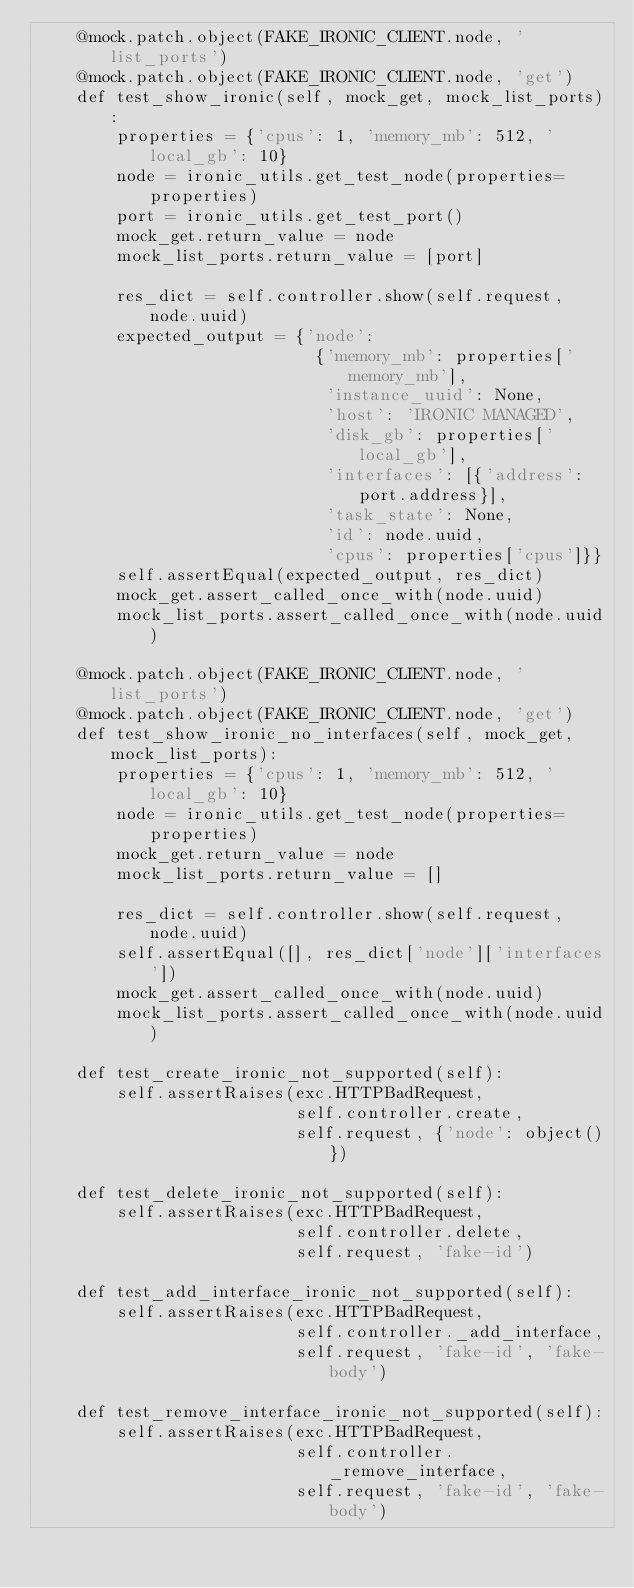<code> <loc_0><loc_0><loc_500><loc_500><_Python_>    @mock.patch.object(FAKE_IRONIC_CLIENT.node, 'list_ports')
    @mock.patch.object(FAKE_IRONIC_CLIENT.node, 'get')
    def test_show_ironic(self, mock_get, mock_list_ports):
        properties = {'cpus': 1, 'memory_mb': 512, 'local_gb': 10}
        node = ironic_utils.get_test_node(properties=properties)
        port = ironic_utils.get_test_port()
        mock_get.return_value = node
        mock_list_ports.return_value = [port]

        res_dict = self.controller.show(self.request, node.uuid)
        expected_output = {'node':
                            {'memory_mb': properties['memory_mb'],
                             'instance_uuid': None,
                             'host': 'IRONIC MANAGED',
                             'disk_gb': properties['local_gb'],
                             'interfaces': [{'address': port.address}],
                             'task_state': None,
                             'id': node.uuid,
                             'cpus': properties['cpus']}}
        self.assertEqual(expected_output, res_dict)
        mock_get.assert_called_once_with(node.uuid)
        mock_list_ports.assert_called_once_with(node.uuid)

    @mock.patch.object(FAKE_IRONIC_CLIENT.node, 'list_ports')
    @mock.patch.object(FAKE_IRONIC_CLIENT.node, 'get')
    def test_show_ironic_no_interfaces(self, mock_get, mock_list_ports):
        properties = {'cpus': 1, 'memory_mb': 512, 'local_gb': 10}
        node = ironic_utils.get_test_node(properties=properties)
        mock_get.return_value = node
        mock_list_ports.return_value = []

        res_dict = self.controller.show(self.request, node.uuid)
        self.assertEqual([], res_dict['node']['interfaces'])
        mock_get.assert_called_once_with(node.uuid)
        mock_list_ports.assert_called_once_with(node.uuid)

    def test_create_ironic_not_supported(self):
        self.assertRaises(exc.HTTPBadRequest,
                          self.controller.create,
                          self.request, {'node': object()})

    def test_delete_ironic_not_supported(self):
        self.assertRaises(exc.HTTPBadRequest,
                          self.controller.delete,
                          self.request, 'fake-id')

    def test_add_interface_ironic_not_supported(self):
        self.assertRaises(exc.HTTPBadRequest,
                          self.controller._add_interface,
                          self.request, 'fake-id', 'fake-body')

    def test_remove_interface_ironic_not_supported(self):
        self.assertRaises(exc.HTTPBadRequest,
                          self.controller._remove_interface,
                          self.request, 'fake-id', 'fake-body')
</code> 